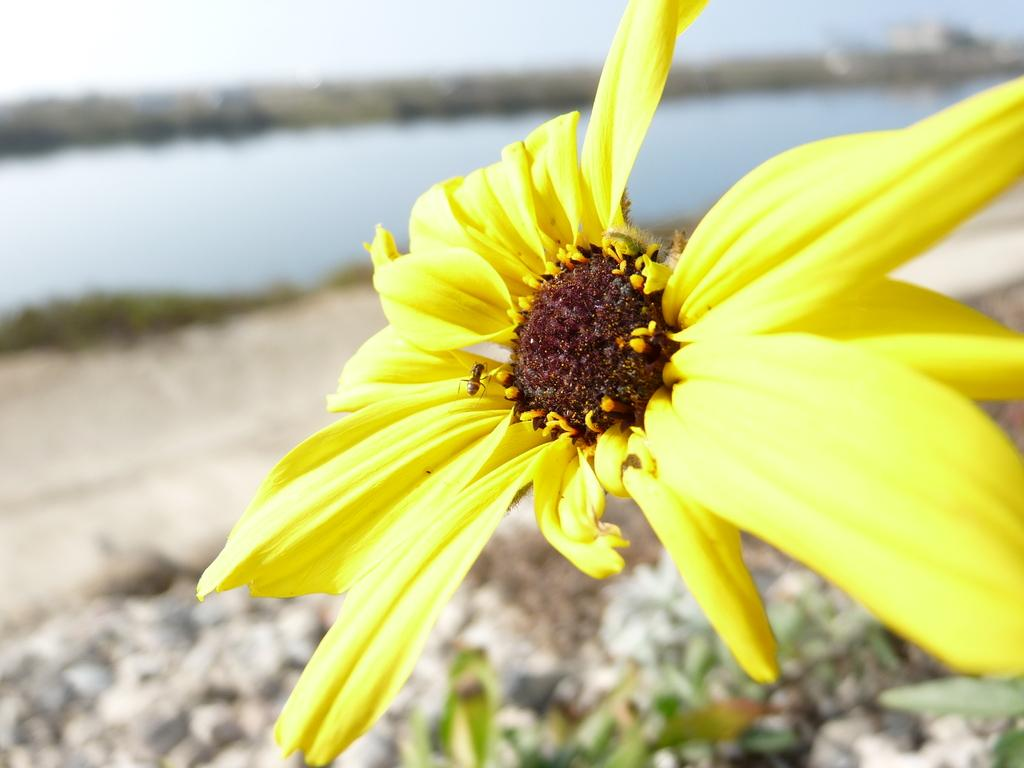What is present in the picture? There is a flower in the picture. What else can be seen in the picture besides the flower? There is water visible in the picture. What is visible in the background of the picture? The sky is visible in the background of the picture. How many fingers can be seen gripping the flower in the picture? There are no fingers or any indication of a person gripping the flower in the picture. 